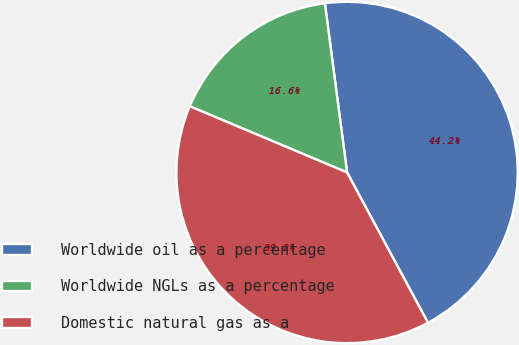Convert chart. <chart><loc_0><loc_0><loc_500><loc_500><pie_chart><fcel>Worldwide oil as a percentage<fcel>Worldwide NGLs as a percentage<fcel>Domestic natural gas as a<nl><fcel>44.22%<fcel>16.58%<fcel>39.2%<nl></chart> 